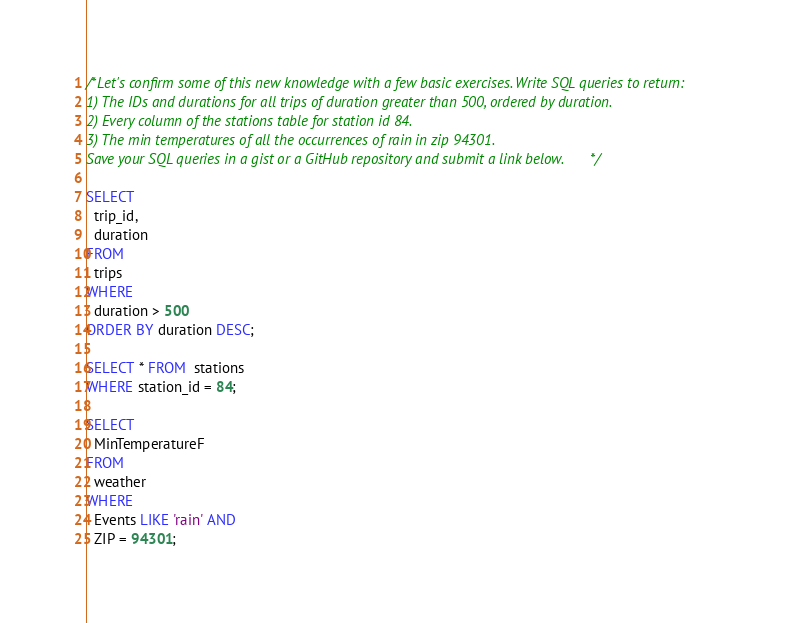Convert code to text. <code><loc_0><loc_0><loc_500><loc_500><_SQL_>/*Let's confirm some of this new knowledge with a few basic exercises. Write SQL queries to return:
1) The IDs and durations for all trips of duration greater than 500, ordered by duration.
2) Every column of the stations table for station id 84.
3) The min temperatures of all the occurrences of rain in zip 94301.
Save your SQL queries in a gist or a GitHub repository and submit a link below. */

SELECT
  trip_id,
  duration
FROM
  trips
WHERE
  duration > 500
ORDER BY duration DESC;

SELECT * FROM  stations
WHERE station_id = 84;

SELECT
  MinTemperatureF
FROM
  weather
WHERE
  Events LIKE 'rain' AND
  ZIP = 94301;
</code> 